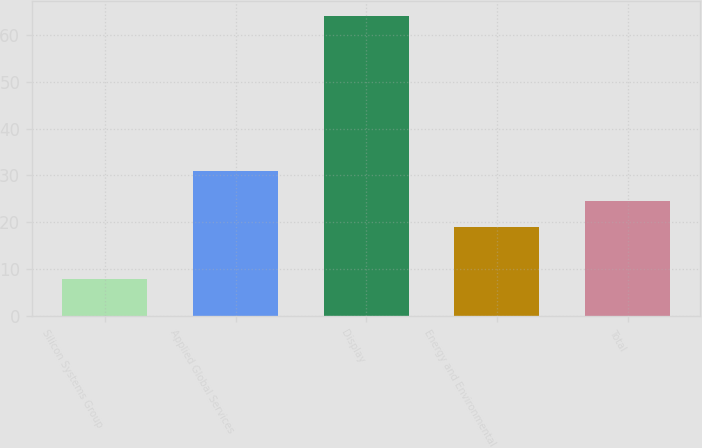<chart> <loc_0><loc_0><loc_500><loc_500><bar_chart><fcel>Silicon Systems Group<fcel>Applied Global Services<fcel>Display<fcel>Energy and Environmental<fcel>Total<nl><fcel>8<fcel>31<fcel>64<fcel>19<fcel>24.6<nl></chart> 